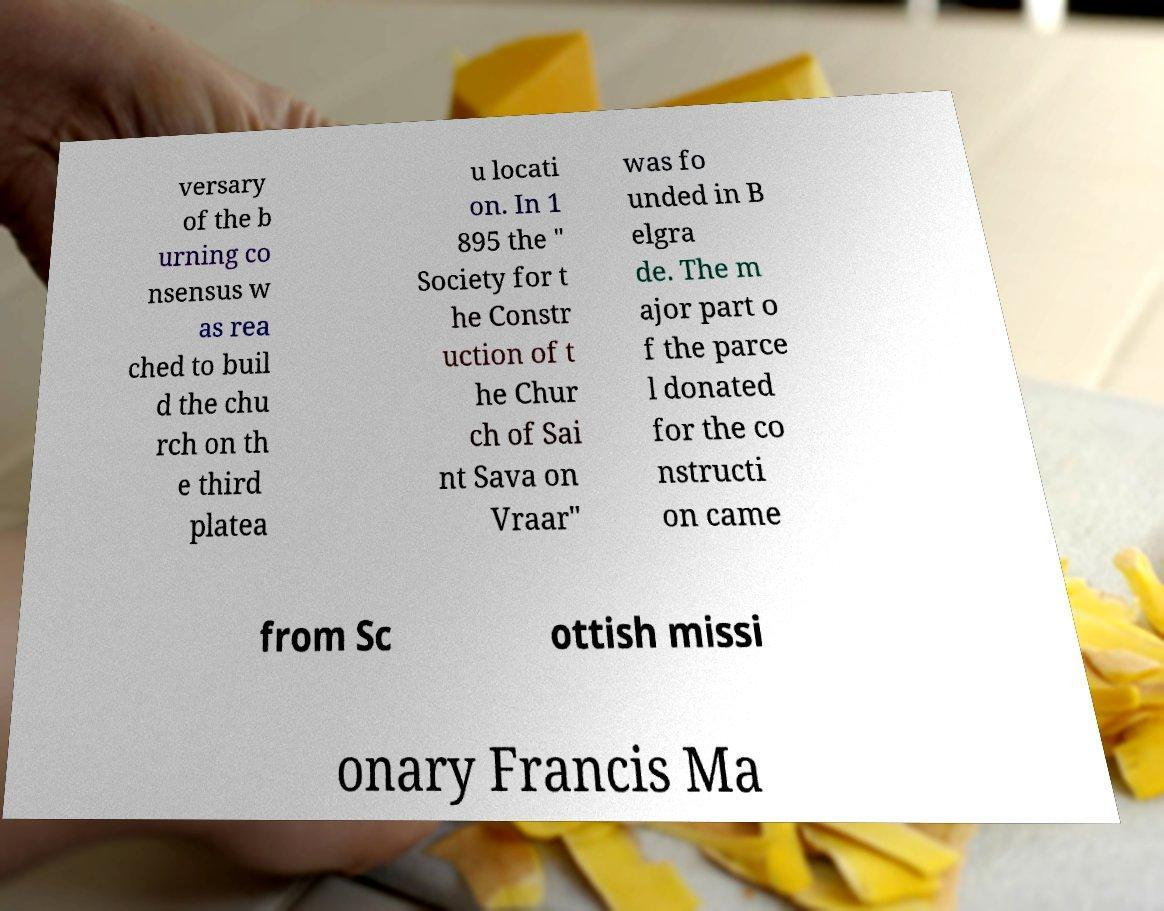Please identify and transcribe the text found in this image. versary of the b urning co nsensus w as rea ched to buil d the chu rch on th e third platea u locati on. In 1 895 the " Society for t he Constr uction of t he Chur ch of Sai nt Sava on Vraar" was fo unded in B elgra de. The m ajor part o f the parce l donated for the co nstructi on came from Sc ottish missi onary Francis Ma 